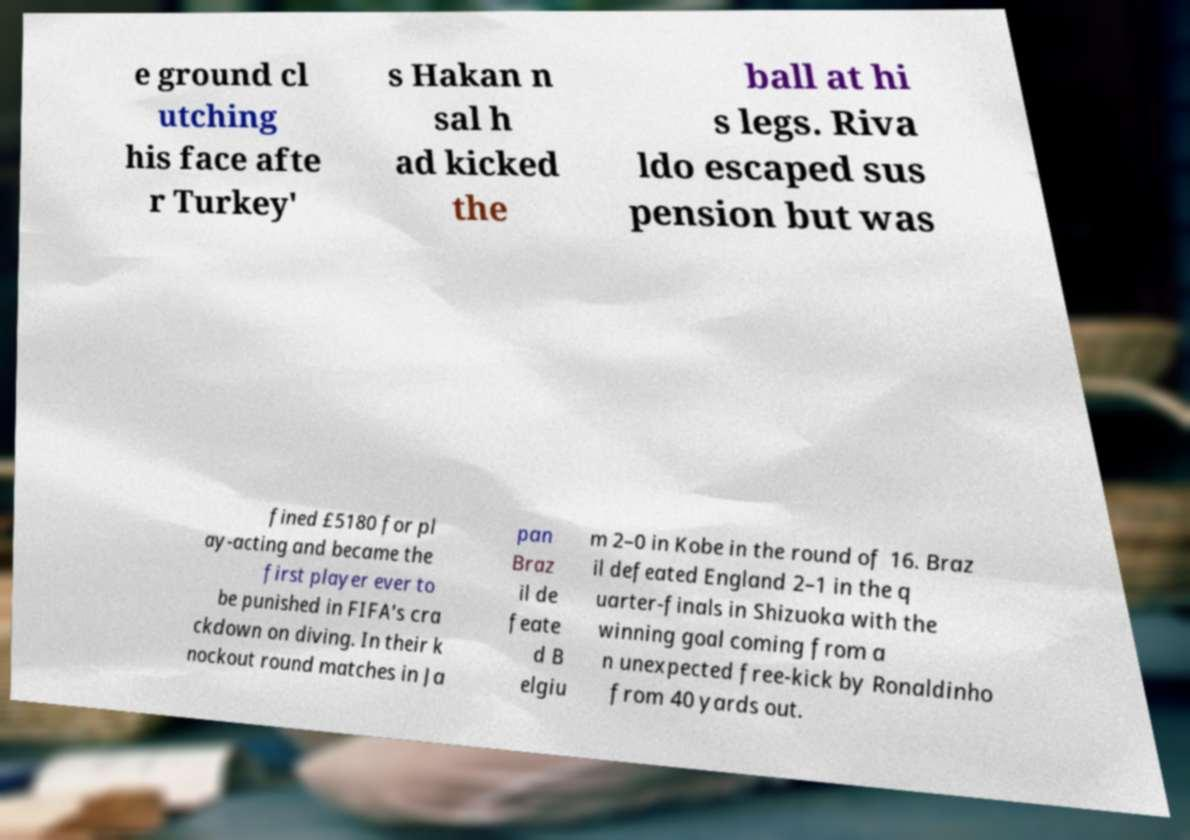Could you assist in decoding the text presented in this image and type it out clearly? e ground cl utching his face afte r Turkey' s Hakan n sal h ad kicked the ball at hi s legs. Riva ldo escaped sus pension but was fined £5180 for pl ay-acting and became the first player ever to be punished in FIFA's cra ckdown on diving. In their k nockout round matches in Ja pan Braz il de feate d B elgiu m 2–0 in Kobe in the round of 16. Braz il defeated England 2–1 in the q uarter-finals in Shizuoka with the winning goal coming from a n unexpected free-kick by Ronaldinho from 40 yards out. 